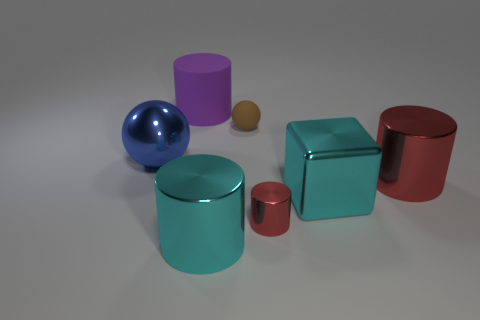How many red cylinders must be subtracted to get 1 red cylinders? 1 Subtract all tiny cylinders. How many cylinders are left? 3 Subtract all gray blocks. How many red cylinders are left? 2 Subtract all purple cylinders. How many cylinders are left? 3 Subtract 2 cylinders. How many cylinders are left? 2 Add 3 gray metallic spheres. How many objects exist? 10 Subtract all purple cylinders. Subtract all blue spheres. How many cylinders are left? 3 Subtract all spheres. How many objects are left? 5 Subtract 0 yellow cylinders. How many objects are left? 7 Subtract all cylinders. Subtract all brown things. How many objects are left? 2 